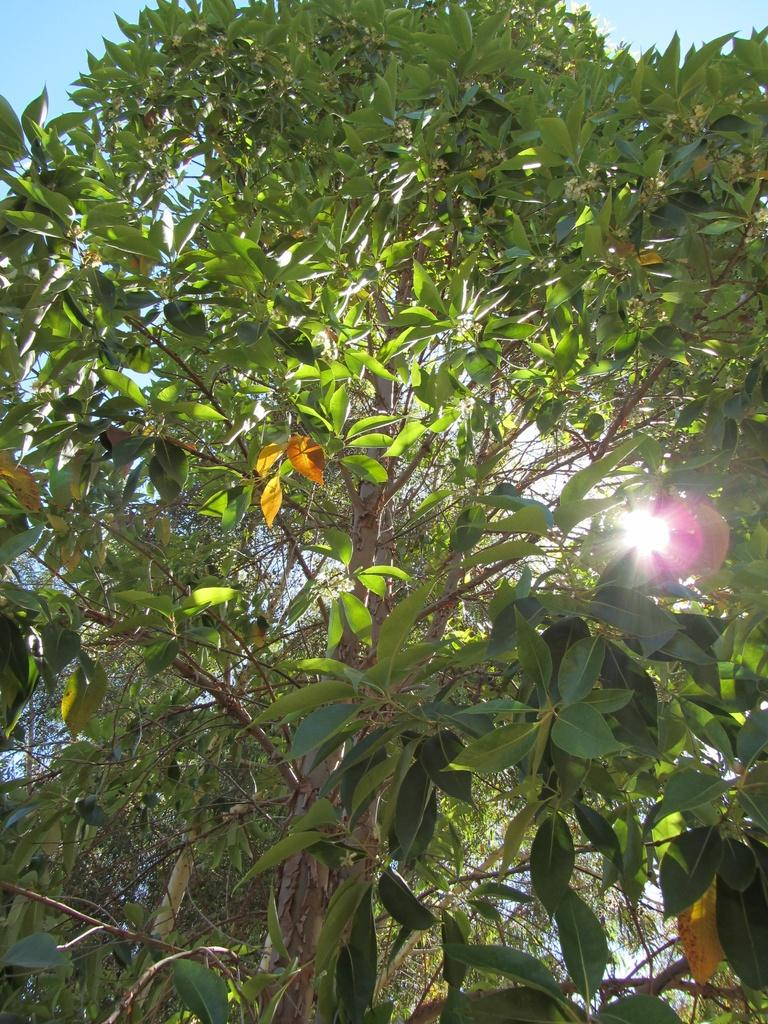What type of vegetation can be seen in the image? There are trees in the image. What celestial body is visible in the sky in the image? The sun is visible in the sky in the image. What is the reason for the trees driving in the image? There is no indication in the image that the trees are driving, as trees do not have the ability to drive. 